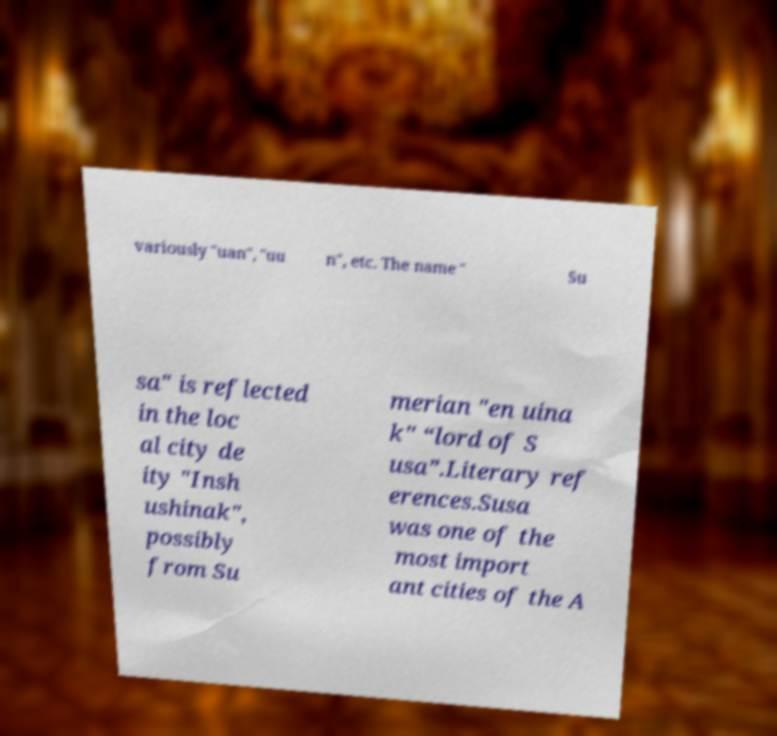There's text embedded in this image that I need extracted. Can you transcribe it verbatim? variously "uan", "uu n", etc. The name " Su sa" is reflected in the loc al city de ity "Insh ushinak", possibly from Su merian "en uina k" “lord of S usa”.Literary ref erences.Susa was one of the most import ant cities of the A 